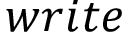Convert formula to latex. <formula><loc_0><loc_0><loc_500><loc_500>w r i t e</formula> 